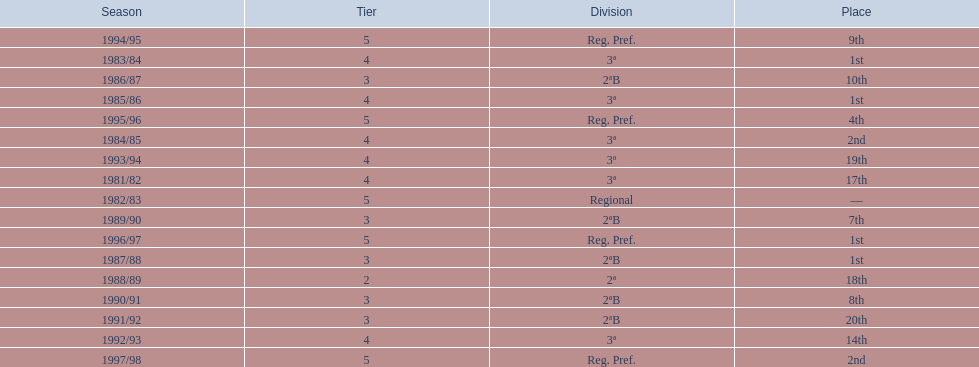Could you parse the entire table? {'header': ['Season', 'Tier', 'Division', 'Place'], 'rows': [['1994/95', '5', 'Reg. Pref.', '9th'], ['1983/84', '4', '3ª', '1st'], ['1986/87', '3', '2ªB', '10th'], ['1985/86', '4', '3ª', '1st'], ['1995/96', '5', 'Reg. Pref.', '4th'], ['1984/85', '4', '3ª', '2nd'], ['1993/94', '4', '3ª', '19th'], ['1981/82', '4', '3ª', '17th'], ['1982/83', '5', 'Regional', '—'], ['1989/90', '3', '2ªB', '7th'], ['1996/97', '5', 'Reg. Pref.', '1st'], ['1987/88', '3', '2ªB', '1st'], ['1988/89', '2', '2ª', '18th'], ['1990/91', '3', '2ªB', '8th'], ['1991/92', '3', '2ªB', '20th'], ['1992/93', '4', '3ª', '14th'], ['1997/98', '5', 'Reg. Pref.', '2nd']]} What year has no place indicated? 1982/83. 